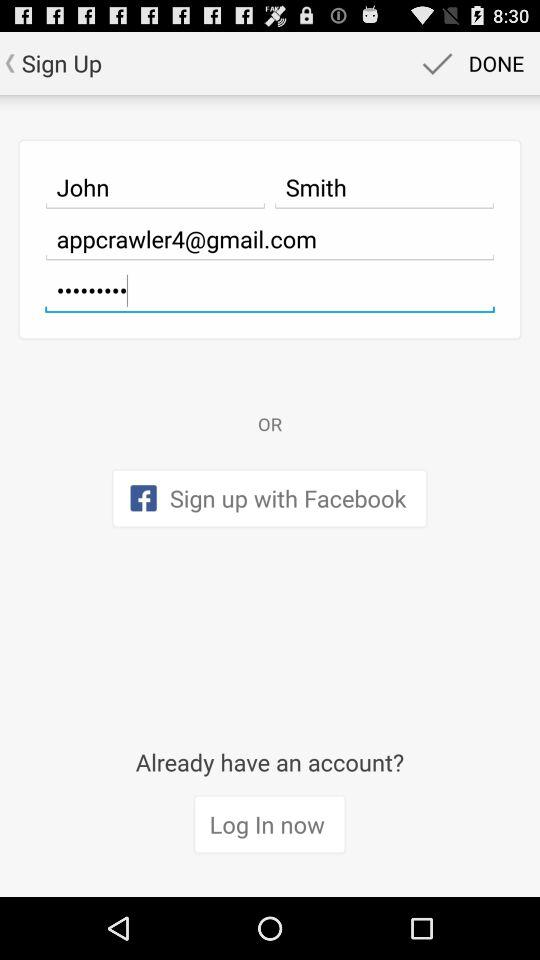Through what application can sign-up be done? Sign-up can be done through "Facebook". 